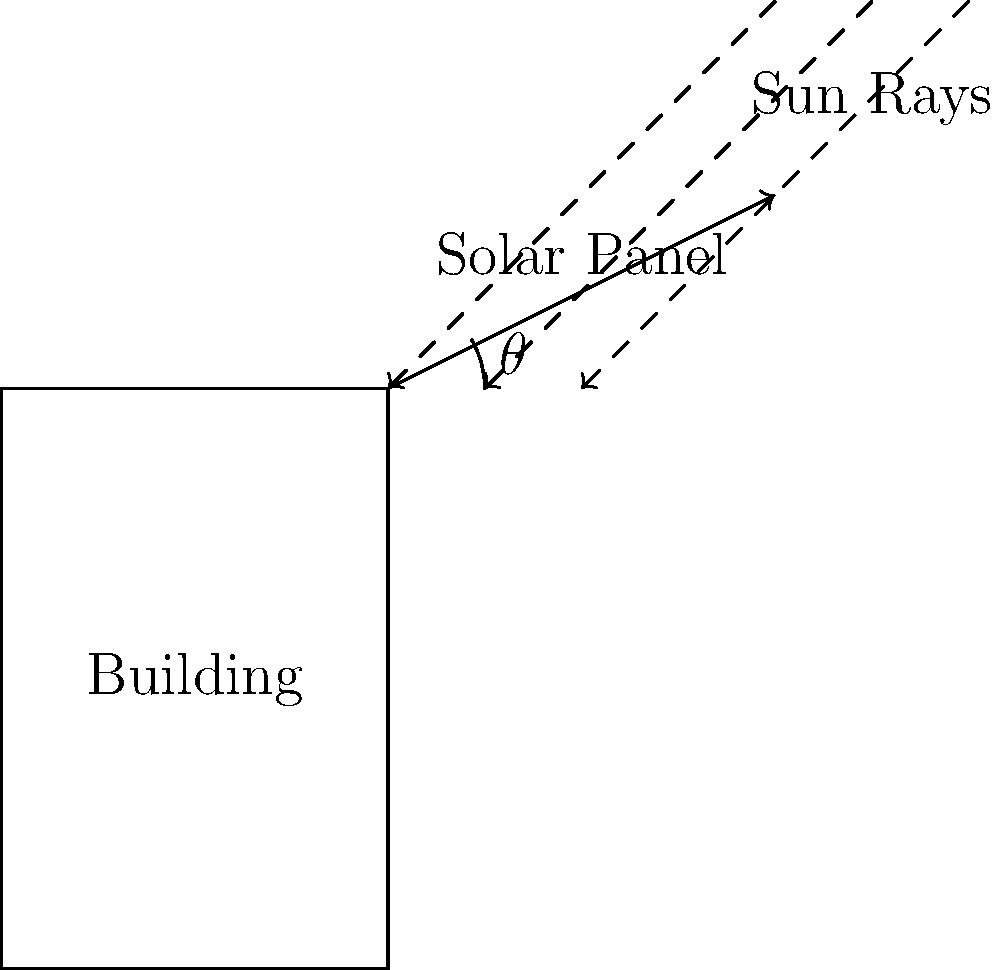A government building plans to install solar panels on its roof. The efficiency of the solar panels depends on the angle at which they are tilted. If the optimal angle $\theta$ for maximum energy absorption is given by the equation $\theta = \arctan(\frac{1}{\cos(L)})$, where $L$ is the latitude of the building's location (38°N), what is the optimal tilt angle for the solar panels? Round your answer to the nearest degree. To solve this problem, we'll follow these steps:

1) We're given the equation: $\theta = \arctan(\frac{1}{\cos(L)})$

2) We know the latitude $L = 38°$

3) First, we need to convert the latitude to radians:
   $38° \times \frac{\pi}{180°} = 0.6632$ radians

4) Now, let's calculate $\cos(L)$:
   $\cos(0.6632) \approx 0.7880$

5) Next, we calculate $\frac{1}{\cos(L)}$:
   $\frac{1}{0.7880} \approx 1.2690$

6) Now we can calculate $\theta$:
   $\theta = \arctan(1.2690)$

7) This gives us $\theta \approx 0.9040$ radians

8) Converting back to degrees:
   $0.9040 \times \frac{180°}{\pi} \approx 51.8°$

9) Rounding to the nearest degree:
   $51.8° \approx 52°$

Therefore, the optimal tilt angle for the solar panels is approximately 52°.
Answer: 52° 